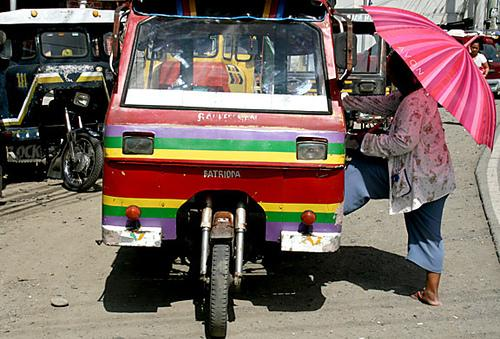What does the front of the automobile shown in this image most resemble?

Choices:
A) rainbow
B) autumn
C) circus
D) sunset rainbow 